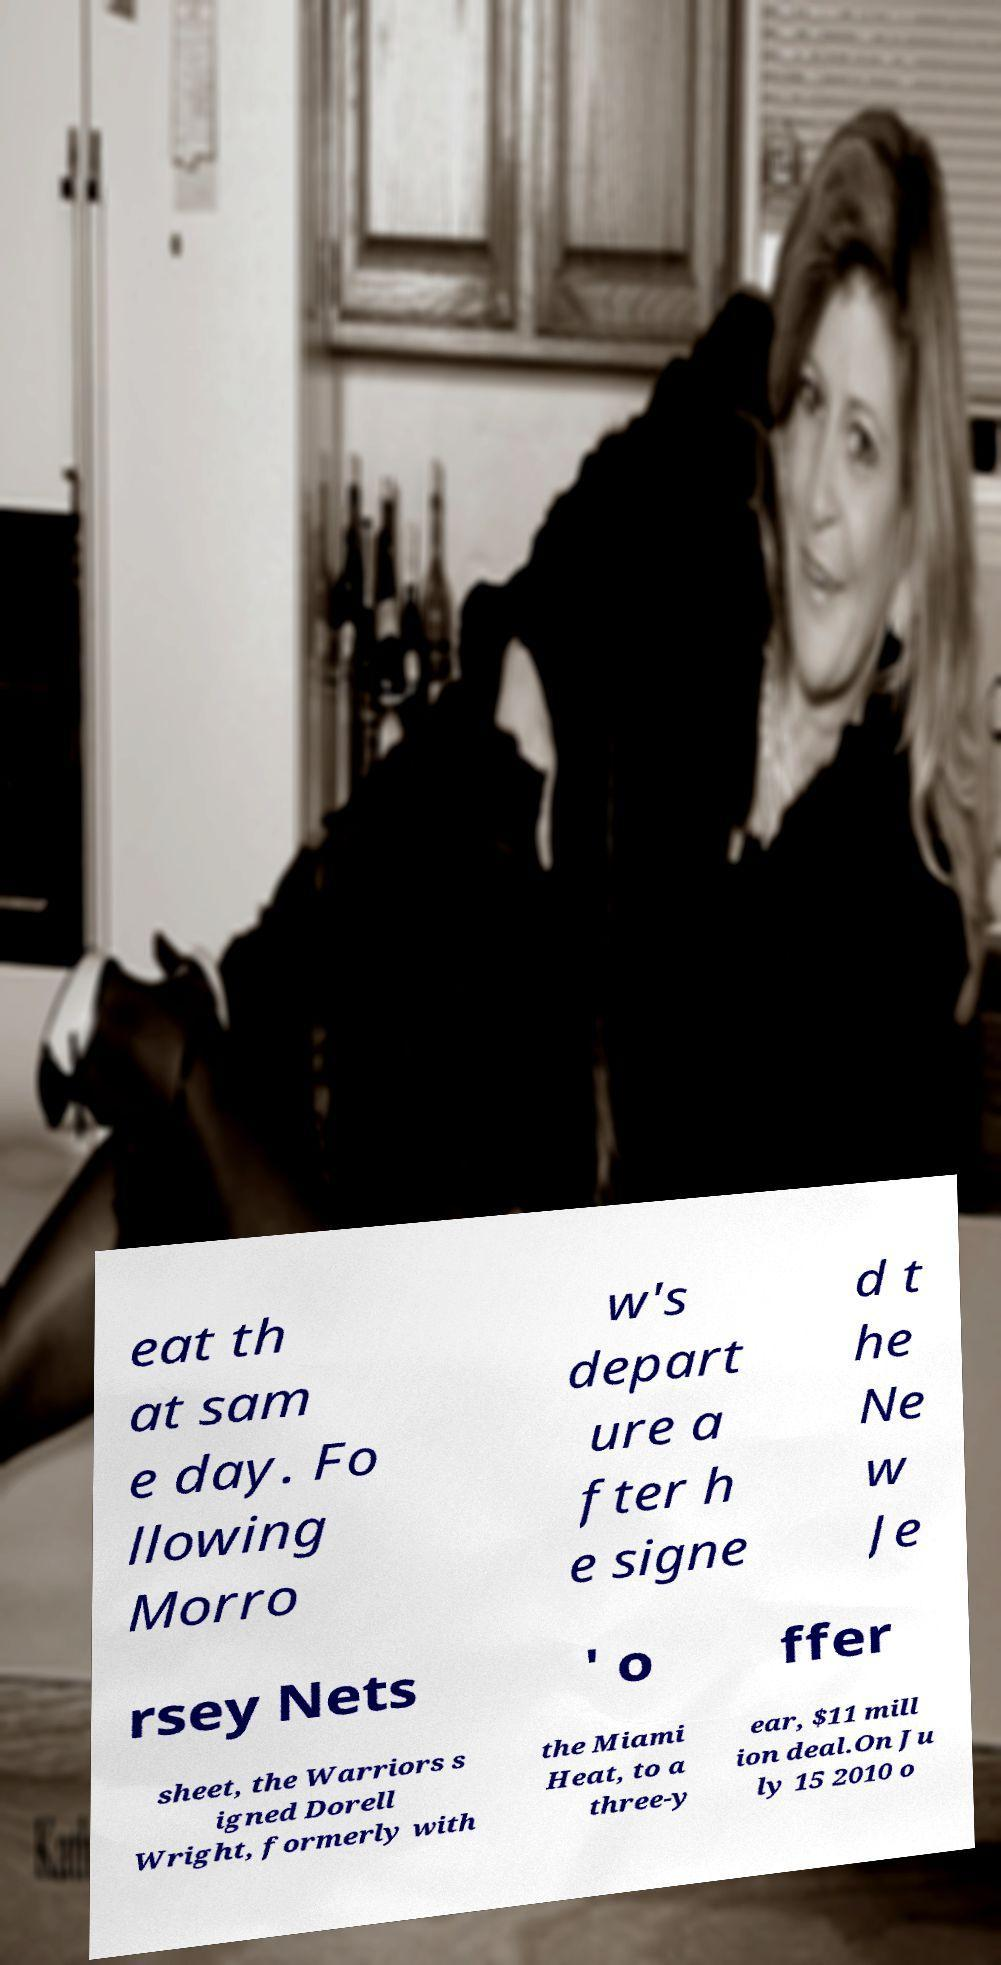Could you extract and type out the text from this image? eat th at sam e day. Fo llowing Morro w's depart ure a fter h e signe d t he Ne w Je rsey Nets ' o ffer sheet, the Warriors s igned Dorell Wright, formerly with the Miami Heat, to a three-y ear, $11 mill ion deal.On Ju ly 15 2010 o 